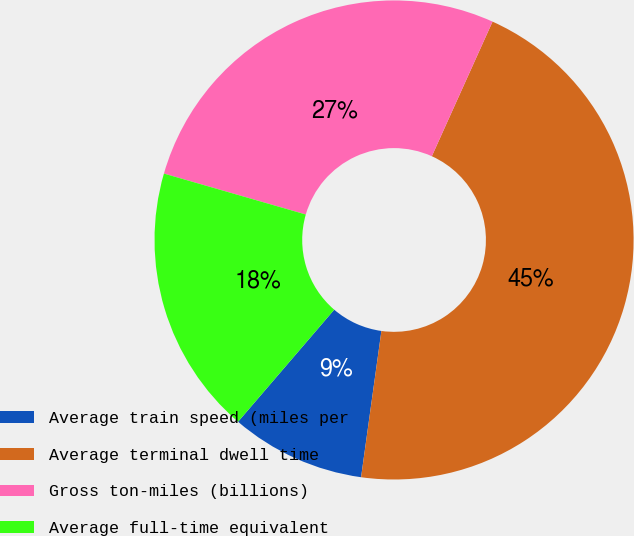Convert chart. <chart><loc_0><loc_0><loc_500><loc_500><pie_chart><fcel>Average train speed (miles per<fcel>Average terminal dwell time<fcel>Gross ton-miles (billions)<fcel>Average full-time equivalent<nl><fcel>9.09%<fcel>45.45%<fcel>27.27%<fcel>18.18%<nl></chart> 